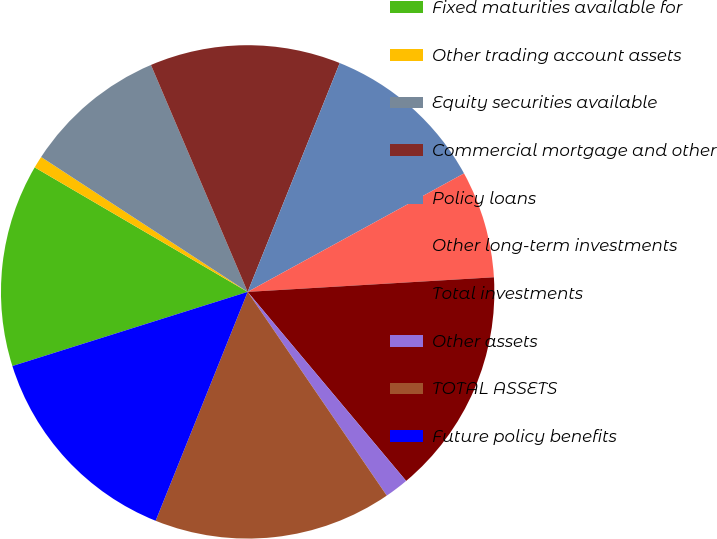Convert chart. <chart><loc_0><loc_0><loc_500><loc_500><pie_chart><fcel>Fixed maturities available for<fcel>Other trading account assets<fcel>Equity securities available<fcel>Commercial mortgage and other<fcel>Policy loans<fcel>Other long-term investments<fcel>Total investments<fcel>Other assets<fcel>TOTAL ASSETS<fcel>Future policy benefits<nl><fcel>13.28%<fcel>0.79%<fcel>9.38%<fcel>12.5%<fcel>10.94%<fcel>7.03%<fcel>14.84%<fcel>1.57%<fcel>15.62%<fcel>14.06%<nl></chart> 